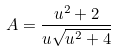Convert formula to latex. <formula><loc_0><loc_0><loc_500><loc_500>A = \frac { u ^ { 2 } + 2 } { u \sqrt { u ^ { 2 } + 4 } }</formula> 